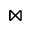<formula> <loc_0><loc_0><loc_500><loc_500>\bowtie</formula> 